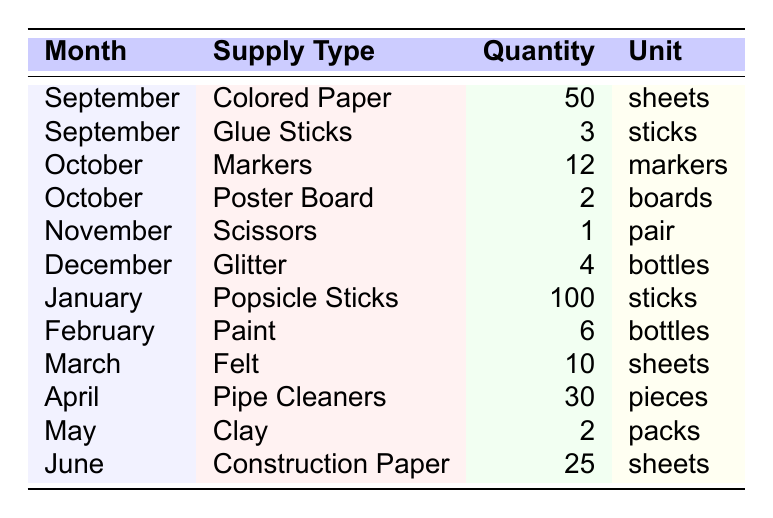What supply type was borrowed the most in January? In January, the table shows that "Popsicle Sticks" had the highest quantity of 100 sticks.
Answer: Popsicle Sticks How many sheets of Colored Paper were used in September? The table indicates that in September, 50 sheets of Colored Paper were used.
Answer: 50 sheets Did any month have Glue Sticks listed in the table? Yes, the table shows that Glue Sticks were used in September, specifically 3 sticks.
Answer: Yes What was the total quantity of craft supplies used in October? In October, there were 12 Markers and 2 Poster Boards. Summing these gives 12 + 2 = 14.
Answer: 14 Which month had the least quantity of supplies listed? In November, only 1 pair of Scissors was used, which is the least compared to other months.
Answer: November How many more sheets of Construction Paper were used than Felt in March? The table shows 10 sheets of Felt in March and 25 sheets of Construction Paper in June. The difference is 25 - 10 = 15.
Answer: 15 sheets Was there any use of Clay before June? The table indicates that Clay was used in May, which is before June.
Answer: Yes What is the average quantity of supplies used each month from September to June? Counting the total quantities: 50 + 3 + 12 + 2 + 1 + 4 + 100 + 6 + 10 + 30 + 2 + 25 = 275. There are 12 months, so the average is 275/12 ≈ 22.92.
Answer: Approximately 22.92 In which month was the highest quantity of Glitter used? The table states that Glitter was used in December, and the quantity was 4 bottles, with no other month showing a higher quantity of that supply.
Answer: December How many supplies were used in total from September to March? Adding the quantities from those months gives: 50 + 3 + 12 + 2 + 1 + 4 + 100 + 6 + 10 = 188.
Answer: 188 